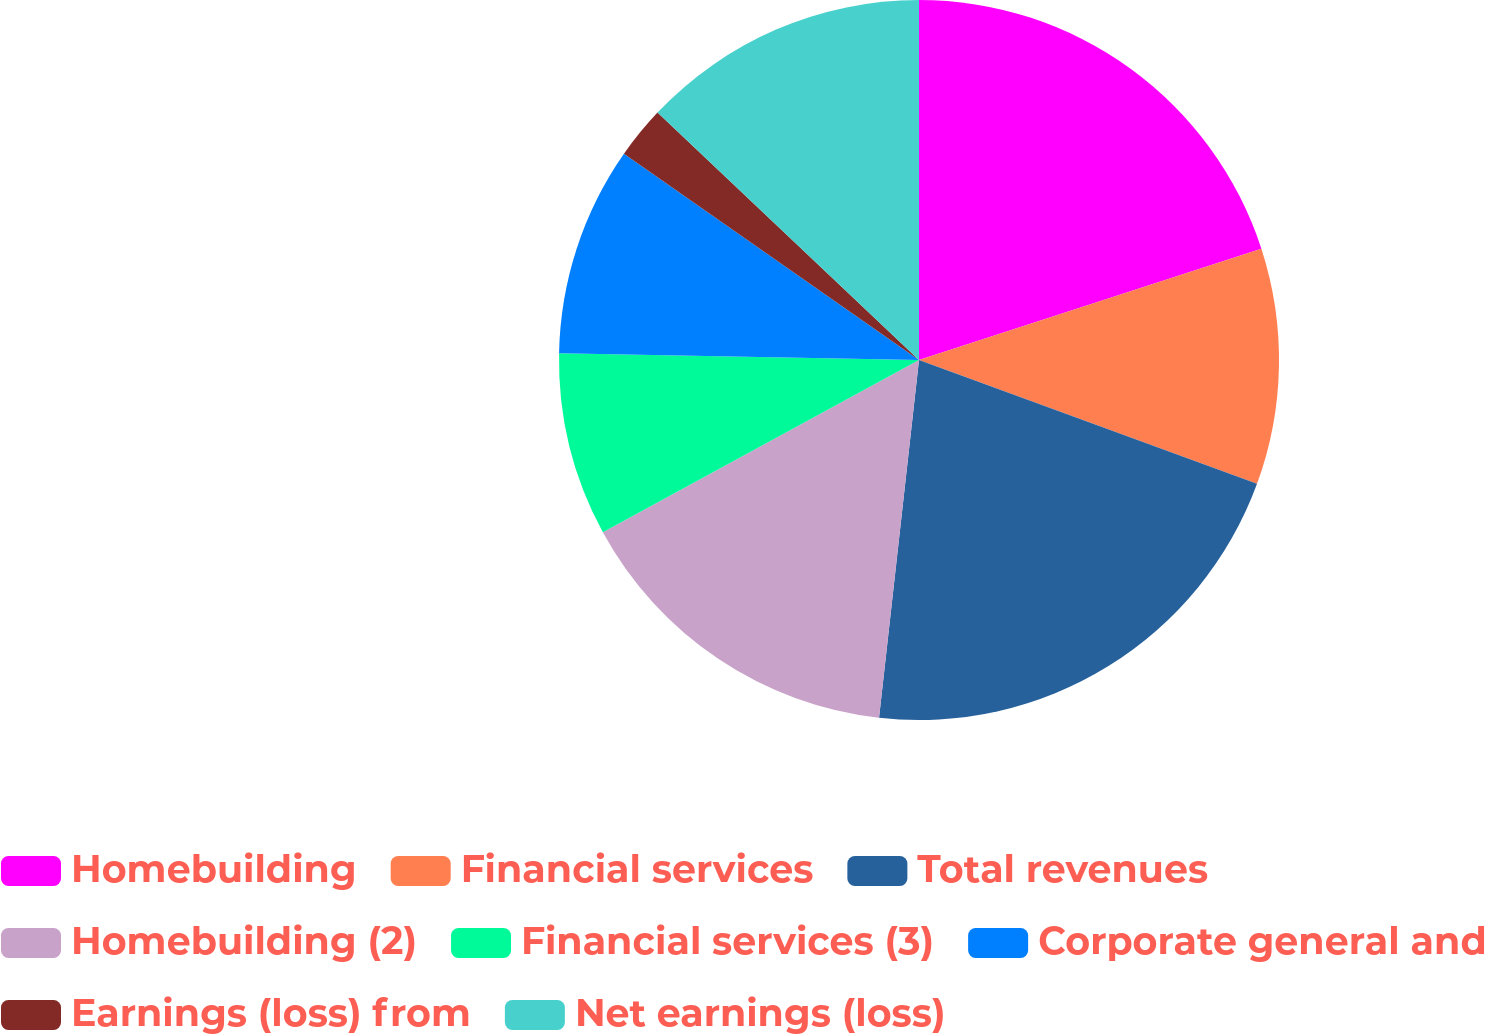Convert chart. <chart><loc_0><loc_0><loc_500><loc_500><pie_chart><fcel>Homebuilding<fcel>Financial services<fcel>Total revenues<fcel>Homebuilding (2)<fcel>Financial services (3)<fcel>Corporate general and<fcel>Earnings (loss) from<fcel>Net earnings (loss)<nl><fcel>20.0%<fcel>10.59%<fcel>21.18%<fcel>15.29%<fcel>8.24%<fcel>9.41%<fcel>2.35%<fcel>12.94%<nl></chart> 